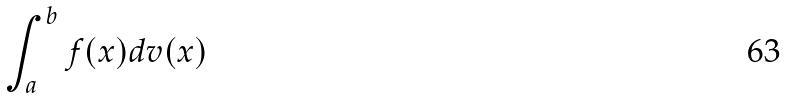<formula> <loc_0><loc_0><loc_500><loc_500>\int _ { a } ^ { b } f ( x ) d v ( x )</formula> 